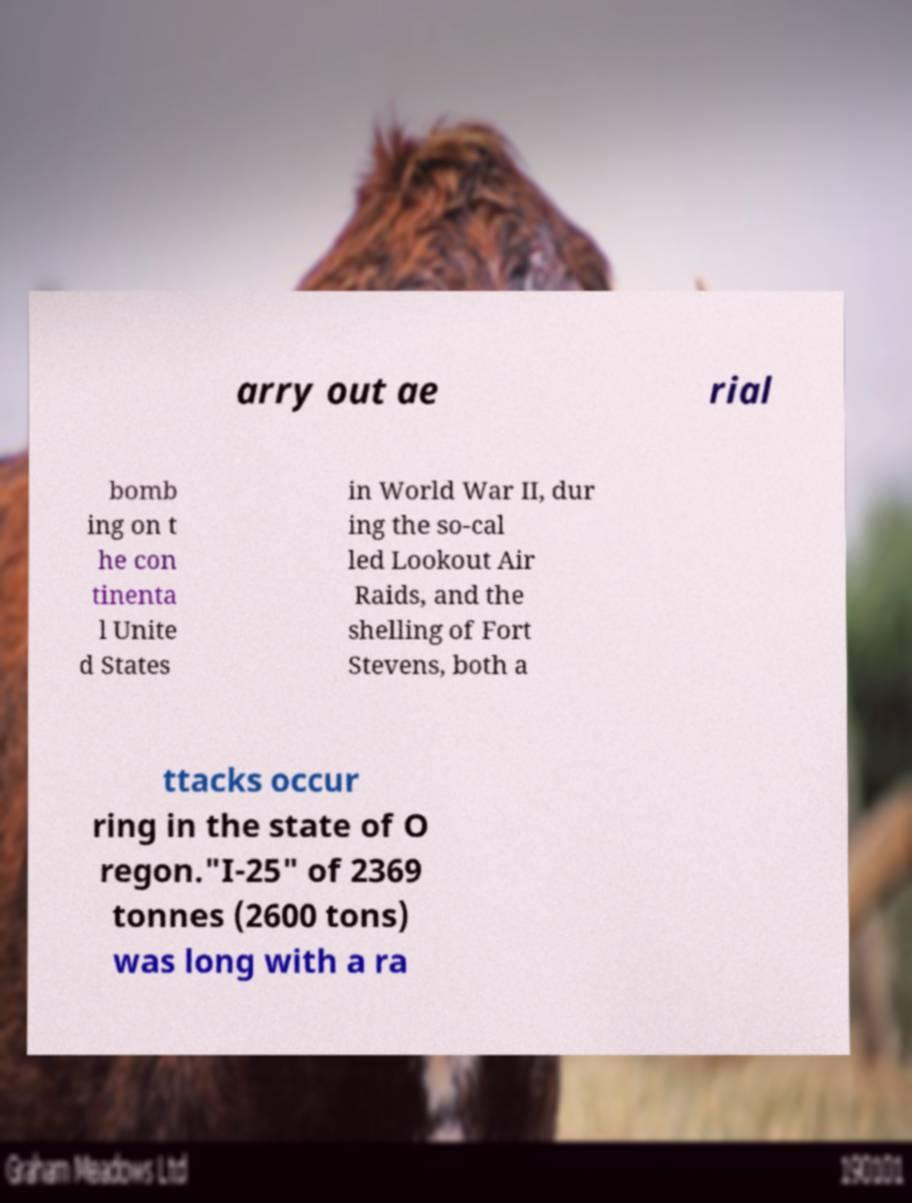I need the written content from this picture converted into text. Can you do that? arry out ae rial bomb ing on t he con tinenta l Unite d States in World War II, dur ing the so-cal led Lookout Air Raids, and the shelling of Fort Stevens, both a ttacks occur ring in the state of O regon."I-25" of 2369 tonnes (2600 tons) was long with a ra 